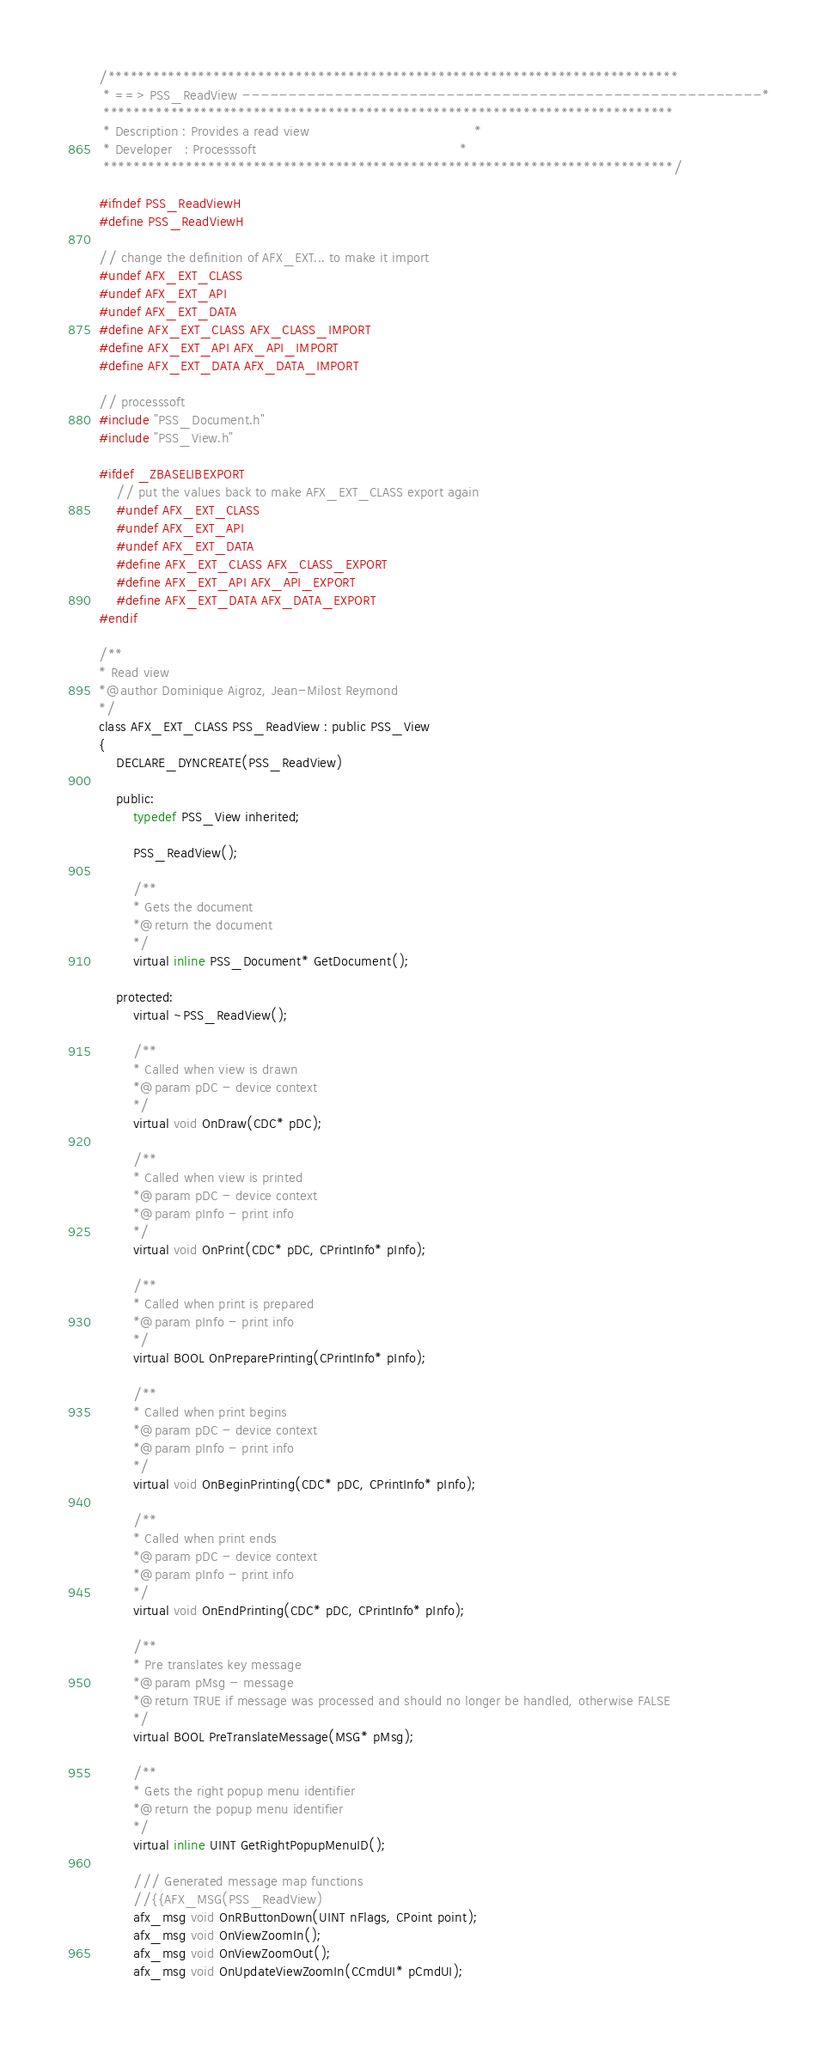<code> <loc_0><loc_0><loc_500><loc_500><_C_>/****************************************************************************
 * ==> PSS_ReadView --------------------------------------------------------*
 ****************************************************************************
 * Description : Provides a read view                                       *
 * Developer   : Processsoft                                                *
 ****************************************************************************/

#ifndef PSS_ReadViewH
#define PSS_ReadViewH

// change the definition of AFX_EXT... to make it import
#undef AFX_EXT_CLASS
#undef AFX_EXT_API
#undef AFX_EXT_DATA
#define AFX_EXT_CLASS AFX_CLASS_IMPORT
#define AFX_EXT_API AFX_API_IMPORT
#define AFX_EXT_DATA AFX_DATA_IMPORT

// processsoft
#include "PSS_Document.h"
#include "PSS_View.h"

#ifdef _ZBASELIBEXPORT
    // put the values back to make AFX_EXT_CLASS export again
    #undef AFX_EXT_CLASS
    #undef AFX_EXT_API
    #undef AFX_EXT_DATA
    #define AFX_EXT_CLASS AFX_CLASS_EXPORT
    #define AFX_EXT_API AFX_API_EXPORT
    #define AFX_EXT_DATA AFX_DATA_EXPORT
#endif

/**
* Read view
*@author Dominique Aigroz, Jean-Milost Reymond
*/
class AFX_EXT_CLASS PSS_ReadView : public PSS_View
{
    DECLARE_DYNCREATE(PSS_ReadView)

    public:
        typedef PSS_View inherited;

        PSS_ReadView();

        /**
        * Gets the document
        *@return the document
        */
        virtual inline PSS_Document* GetDocument();

    protected:
        virtual ~PSS_ReadView();

        /**
        * Called when view is drawn
        *@param pDC - device context
        */
        virtual void OnDraw(CDC* pDC);

        /**
        * Called when view is printed
        *@param pDC - device context
        *@param pInfo - print info
        */
        virtual void OnPrint(CDC* pDC, CPrintInfo* pInfo);

        /**
        * Called when print is prepared
        *@param pInfo - print info
        */
        virtual BOOL OnPreparePrinting(CPrintInfo* pInfo);

        /**
        * Called when print begins
        *@param pDC - device context
        *@param pInfo - print info
        */
        virtual void OnBeginPrinting(CDC* pDC, CPrintInfo* pInfo);

        /**
        * Called when print ends
        *@param pDC - device context
        *@param pInfo - print info
        */
        virtual void OnEndPrinting(CDC* pDC, CPrintInfo* pInfo);

        /**
        * Pre translates key message
        *@param pMsg - message
        *@return TRUE if message was processed and should no longer be handled, otherwise FALSE
        */
        virtual BOOL PreTranslateMessage(MSG* pMsg);

        /**
        * Gets the right popup menu identifier
        *@return the popup menu identifier
        */
        virtual inline UINT GetRightPopupMenuID();

        /// Generated message map functions
        //{{AFX_MSG(PSS_ReadView)
        afx_msg void OnRButtonDown(UINT nFlags, CPoint point);
        afx_msg void OnViewZoomIn();
        afx_msg void OnViewZoomOut();
        afx_msg void OnUpdateViewZoomIn(CCmdUI* pCmdUI);</code> 